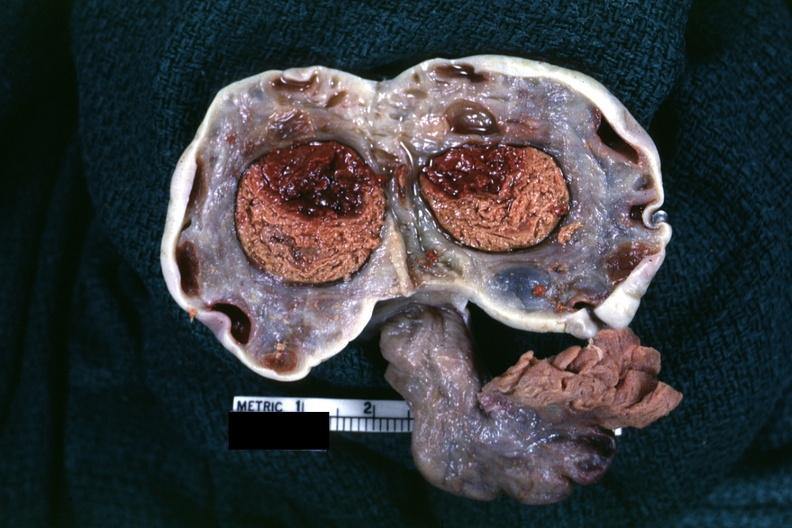did ml not mention?
Answer the question using a single word or phrase. No 